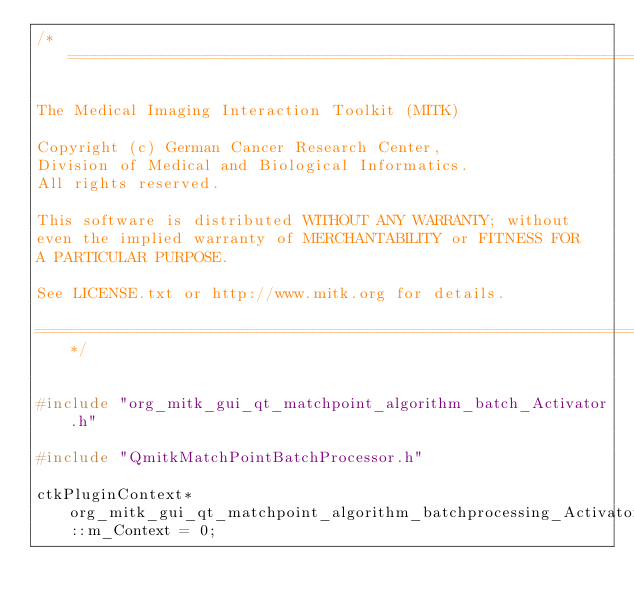<code> <loc_0><loc_0><loc_500><loc_500><_C++_>/*===================================================================

The Medical Imaging Interaction Toolkit (MITK)

Copyright (c) German Cancer Research Center,
Division of Medical and Biological Informatics.
All rights reserved.

This software is distributed WITHOUT ANY WARRANTY; without
even the implied warranty of MERCHANTABILITY or FITNESS FOR
A PARTICULAR PURPOSE.

See LICENSE.txt or http://www.mitk.org for details.

===================================================================*/


#include "org_mitk_gui_qt_matchpoint_algorithm_batch_Activator.h"

#include "QmitkMatchPointBatchProcessor.h"

ctkPluginContext* org_mitk_gui_qt_matchpoint_algorithm_batchprocessing_Activator::m_Context = 0;
</code> 